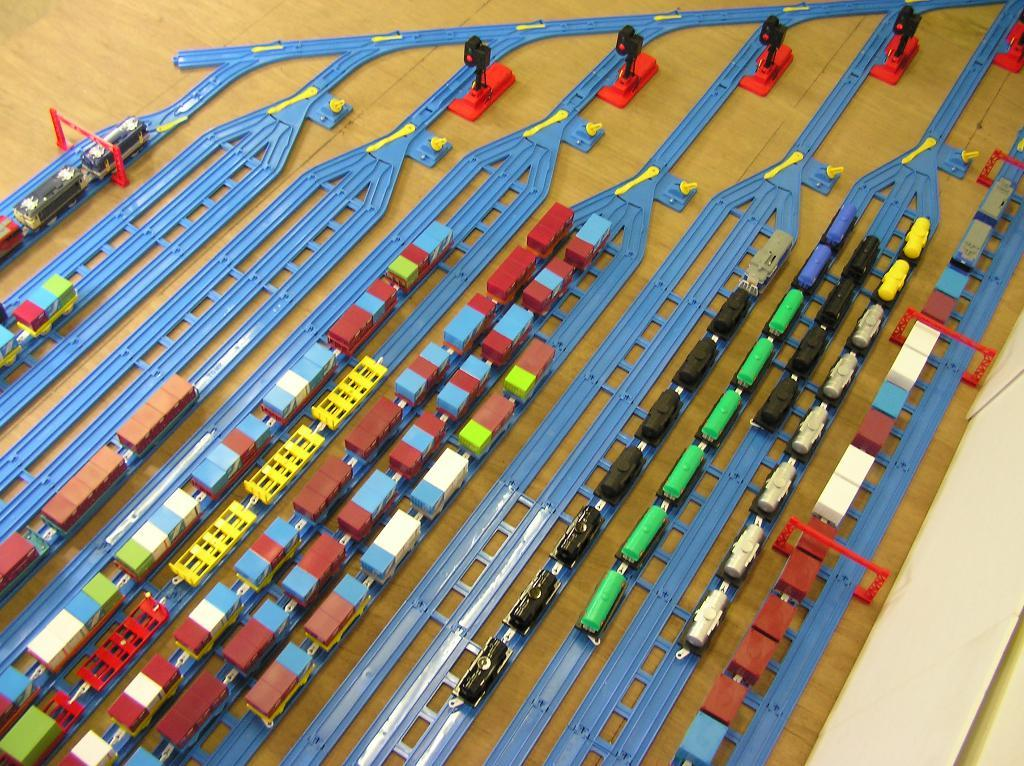What type of vehicles are present in the image? There are trains in the image. What are the trains traveling on? There are tracks in the image for the trains to travel on. What else can be seen in the image besides the trains and tracks? There are poles in the image. On what surface are all these elements located? All these elements are on a surface. What type of food is being rewarded to the trains in the image? There is no food or reward being given to the trains in the image; it only shows trains, tracks, and poles. 